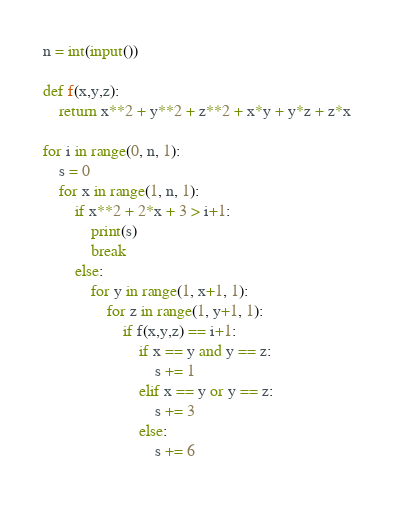<code> <loc_0><loc_0><loc_500><loc_500><_Python_>n = int(input())

def f(x,y,z):
    return x**2 + y**2 + z**2 + x*y + y*z + z*x

for i in range(0, n, 1):
    s = 0
    for x in range(1, n, 1):
        if x**2 + 2*x + 3 > i+1:
            print(s)
            break
        else:
            for y in range(1, x+1, 1):
                for z in range(1, y+1, 1):
                    if f(x,y,z) == i+1:
                        if x == y and y == z:
                            s += 1
                        elif x == y or y == z:
                            s += 3
                        else:
                            s += 6
                        
</code> 